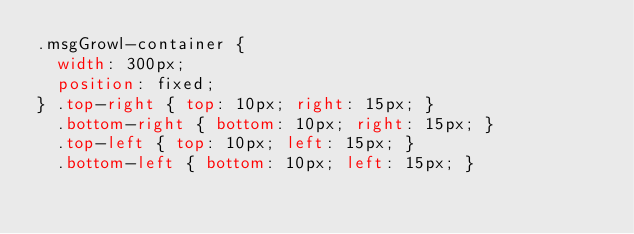<code> <loc_0><loc_0><loc_500><loc_500><_CSS_>.msgGrowl-container {
	width: 300px;
	position: fixed;
}	.top-right { top: 10px; right: 15px; }
	.bottom-right { bottom: 10px; right: 15px; }
	.top-left { top: 10px; left: 15px; }
	.bottom-left { bottom: 10px; left: 15px; }</code> 